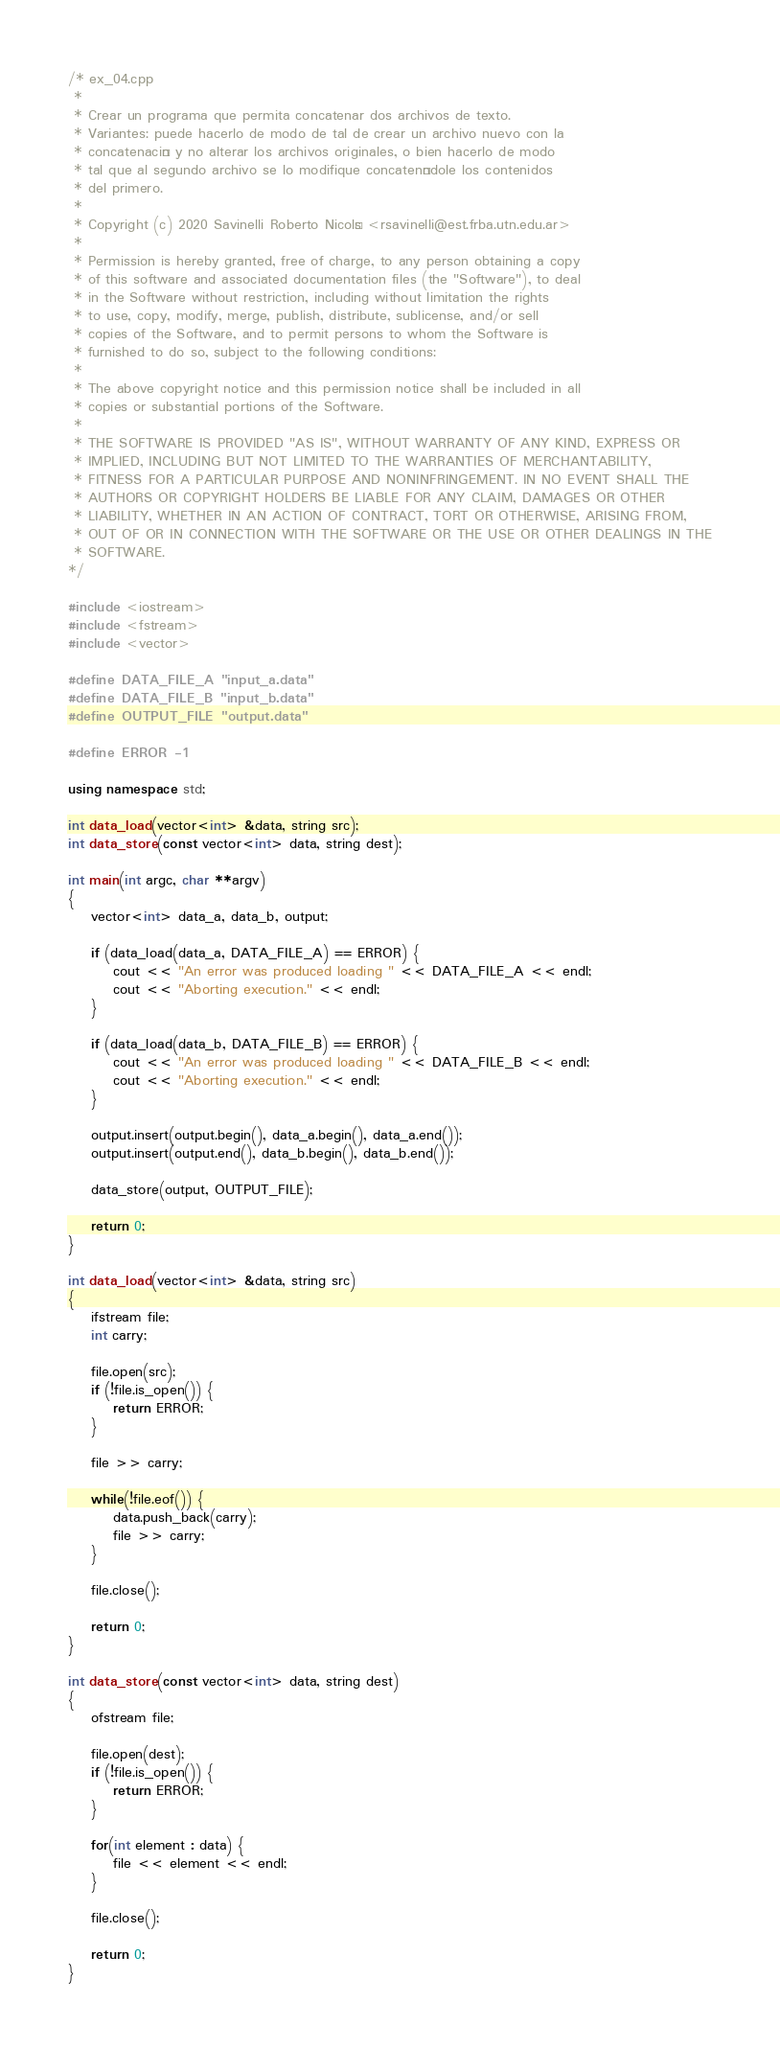Convert code to text. <code><loc_0><loc_0><loc_500><loc_500><_C++_>/* ex_04.cpp
 *
 * Crear un programa que permita concatenar dos archivos de texto.
 * Variantes: puede hacerlo de modo de tal de crear un archivo nuevo con la
 * concatenación y no alterar los archivos originales, o bien hacerlo de modo
 * tal que al segundo archivo se lo modifique concatenándole los contenidos
 * del primero.
 *
 * Copyright (c) 2020 Savinelli Roberto Nicolás <rsavinelli@est.frba.utn.edu.ar>
 *
 * Permission is hereby granted, free of charge, to any person obtaining a copy
 * of this software and associated documentation files (the "Software"), to deal
 * in the Software without restriction, including without limitation the rights
 * to use, copy, modify, merge, publish, distribute, sublicense, and/or sell
 * copies of the Software, and to permit persons to whom the Software is
 * furnished to do so, subject to the following conditions:
 *
 * The above copyright notice and this permission notice shall be included in all
 * copies or substantial portions of the Software.
 *
 * THE SOFTWARE IS PROVIDED "AS IS", WITHOUT WARRANTY OF ANY KIND, EXPRESS OR
 * IMPLIED, INCLUDING BUT NOT LIMITED TO THE WARRANTIES OF MERCHANTABILITY,
 * FITNESS FOR A PARTICULAR PURPOSE AND NONINFRINGEMENT. IN NO EVENT SHALL THE
 * AUTHORS OR COPYRIGHT HOLDERS BE LIABLE FOR ANY CLAIM, DAMAGES OR OTHER
 * LIABILITY, WHETHER IN AN ACTION OF CONTRACT, TORT OR OTHERWISE, ARISING FROM,
 * OUT OF OR IN CONNECTION WITH THE SOFTWARE OR THE USE OR OTHER DEALINGS IN THE
 * SOFTWARE.
*/

#include <iostream>
#include <fstream>
#include <vector>

#define DATA_FILE_A "input_a.data"
#define DATA_FILE_B "input_b.data"
#define OUTPUT_FILE "output.data"

#define ERROR -1

using namespace std;

int data_load(vector<int> &data, string src);
int data_store(const vector<int> data, string dest);

int main(int argc, char **argv)
{
	vector<int> data_a, data_b, output;

	if (data_load(data_a, DATA_FILE_A) == ERROR) {
		cout << "An error was produced loading " << DATA_FILE_A << endl;
		cout << "Aborting execution." << endl;
	}

	if (data_load(data_b, DATA_FILE_B) == ERROR) {
		cout << "An error was produced loading " << DATA_FILE_B << endl;
		cout << "Aborting execution." << endl;
	}

	output.insert(output.begin(), data_a.begin(), data_a.end());
	output.insert(output.end(), data_b.begin(), data_b.end());

	data_store(output, OUTPUT_FILE);

	return 0;
}

int data_load(vector<int> &data, string src)
{
	ifstream file;
	int carry;

	file.open(src);
	if (!file.is_open()) {
		return ERROR;
	}

	file >> carry;

	while(!file.eof()) {
		data.push_back(carry);
		file >> carry;
	}

	file.close();

	return 0;
}

int data_store(const vector<int> data, string dest)
{
	ofstream file;

	file.open(dest);
	if (!file.is_open()) {
		return ERROR;
	}

	for(int element : data) {
		file << element << endl;
	}

	file.close();

	return 0;
}
</code> 